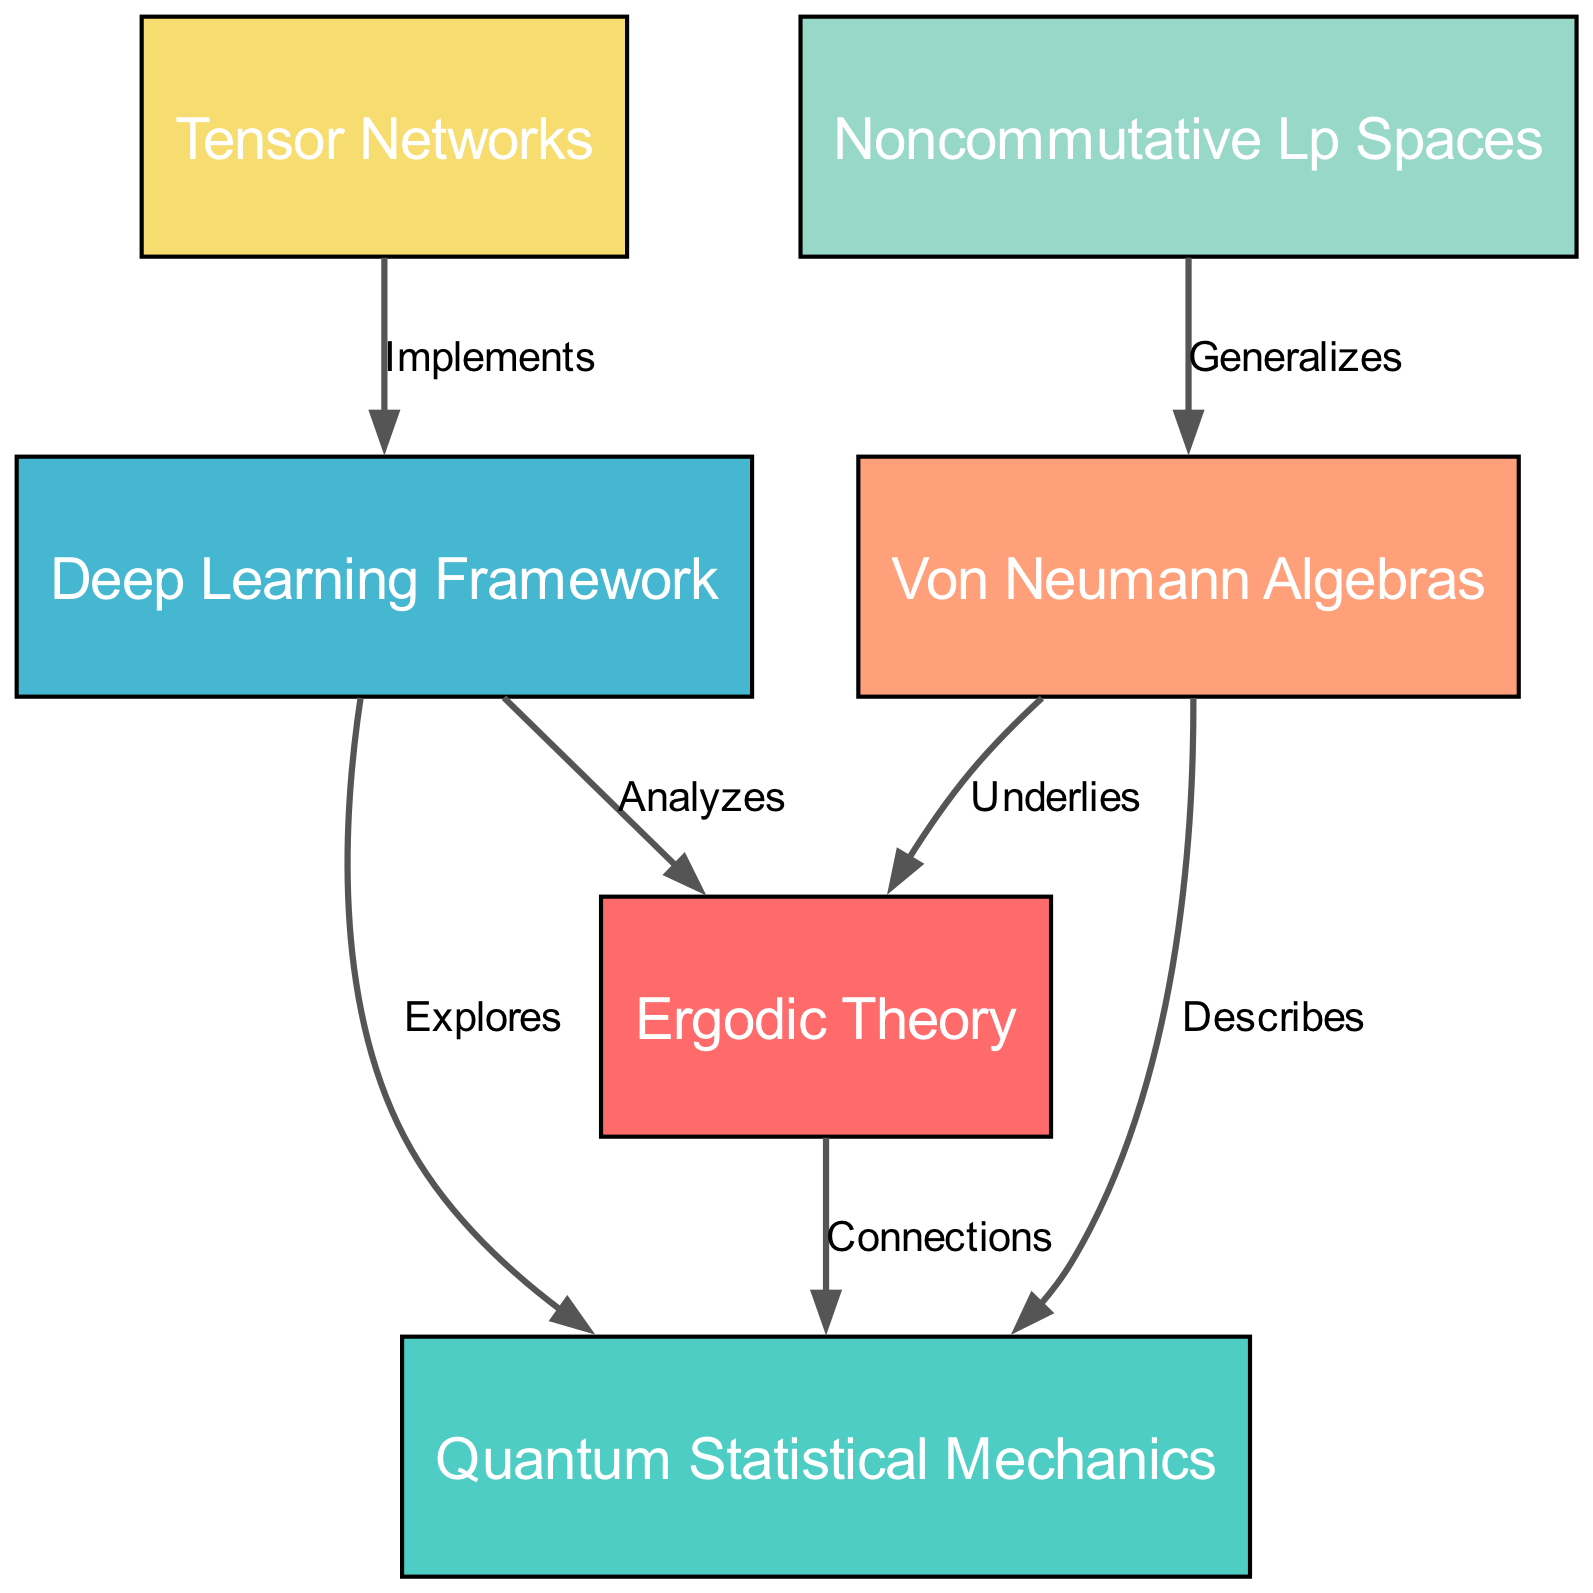What are the main subjects of this diagram? The main subjects are listed as nodes in the diagram, which are: Ergodic Theory, Quantum Statistical Mechanics, Deep Learning Framework, Von Neumann Algebras, Noncommutative Lp Spaces, and Tensor Networks.
Answer: Ergodic Theory, Quantum Statistical Mechanics, Deep Learning Framework, Von Neumann Algebras, Noncommutative Lp Spaces, Tensor Networks How many edges are present in the diagram? The diagram has a total of six edges connecting various nodes, illustrated by the lines linking them.
Answer: Six What relationship does the Deep Learning Framework have with Ergodic Theory? The label on the edge connecting the Deep Learning Framework and Ergodic Theory indicates that the framework "Analyzes" Ergodic Theory. This is described directly on the edge connecting them.
Answer: Analyzes Which node is described by Von Neumann Algebras? There are two edges originating from Von Neumann Algebras, one leading to Ergodic Theory labeled "Underlies" and another leading to Quantum Statistical Mechanics labeled "Describes." Therefore, it describes Quantum Statistical Mechanics.
Answer: Quantum Statistical Mechanics What is the relationship between Noncommutative Lp Spaces and Von Neumann Algebras? The diagram indicates a connection where Noncommutative Lp Spaces "Generalizes" Von Neumann Algebras. This is indicated by the directed edge between them in the diagram.
Answer: Generalizes Which node implements the Deep Learning Framework? Looking at the edges, Tensor Networks have a direct relationship that states "Implements" the Deep Learning Framework, confirming the connection represented in the diagram.
Answer: Tensor Networks What type of connections exist between Ergodic Theory and Quantum Statistical Mechanics? The diagram indicates a direct connection labeled "Connections" between these two fields, suggesting an academic or theoretical linkage depicted in the diagram.
Answer: Connections How does the Deep Learning Framework relate to Quantum Statistical Mechanics? The edge connecting the Deep Learning Framework and Quantum Statistical Mechanics notes that the framework "Explores" this field, showcasing its role in investigating or delving into Quantum Statistical Mechanics.
Answer: Explores 